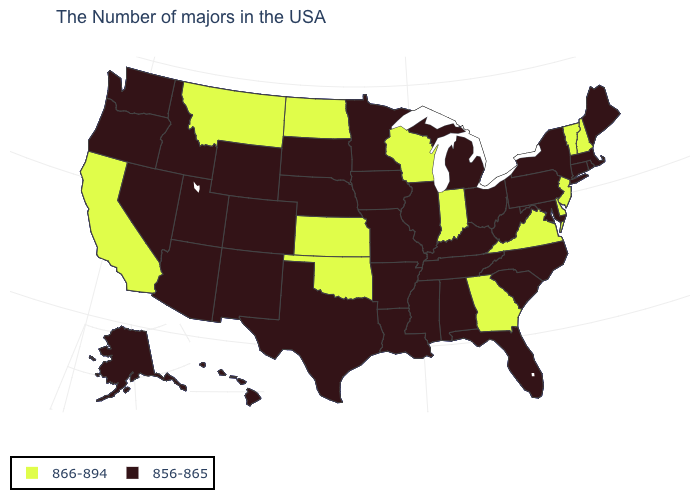Name the states that have a value in the range 856-865?
Keep it brief. Maine, Massachusetts, Rhode Island, Connecticut, New York, Maryland, Pennsylvania, North Carolina, South Carolina, West Virginia, Ohio, Florida, Michigan, Kentucky, Alabama, Tennessee, Illinois, Mississippi, Louisiana, Missouri, Arkansas, Minnesota, Iowa, Nebraska, Texas, South Dakota, Wyoming, Colorado, New Mexico, Utah, Arizona, Idaho, Nevada, Washington, Oregon, Alaska, Hawaii. What is the value of Oklahoma?
Concise answer only. 866-894. What is the value of Maryland?
Keep it brief. 856-865. Does Indiana have the same value as Montana?
Answer briefly. Yes. Name the states that have a value in the range 856-865?
Keep it brief. Maine, Massachusetts, Rhode Island, Connecticut, New York, Maryland, Pennsylvania, North Carolina, South Carolina, West Virginia, Ohio, Florida, Michigan, Kentucky, Alabama, Tennessee, Illinois, Mississippi, Louisiana, Missouri, Arkansas, Minnesota, Iowa, Nebraska, Texas, South Dakota, Wyoming, Colorado, New Mexico, Utah, Arizona, Idaho, Nevada, Washington, Oregon, Alaska, Hawaii. Does South Dakota have the same value as Arizona?
Write a very short answer. Yes. What is the value of Maryland?
Be succinct. 856-865. What is the lowest value in the USA?
Concise answer only. 856-865. What is the value of Pennsylvania?
Quick response, please. 856-865. Does California have the lowest value in the USA?
Short answer required. No. Does Nevada have a higher value than Mississippi?
Quick response, please. No. Does South Dakota have the lowest value in the USA?
Concise answer only. Yes. Does New Hampshire have the highest value in the Northeast?
Quick response, please. Yes. Name the states that have a value in the range 866-894?
Write a very short answer. New Hampshire, Vermont, New Jersey, Delaware, Virginia, Georgia, Indiana, Wisconsin, Kansas, Oklahoma, North Dakota, Montana, California. 